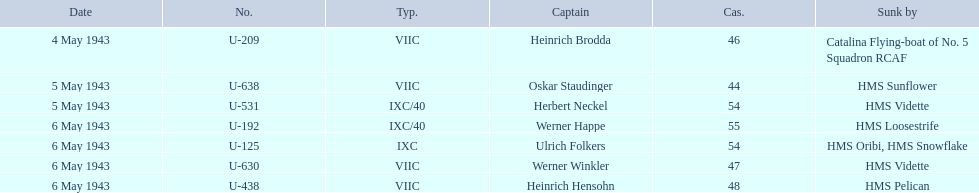Who are all of the captains? Heinrich Brodda, Oskar Staudinger, Herbert Neckel, Werner Happe, Ulrich Folkers, Werner Winkler, Heinrich Hensohn. What sunk each of the captains? Catalina Flying-boat of No. 5 Squadron RCAF, HMS Sunflower, HMS Vidette, HMS Loosestrife, HMS Oribi, HMS Snowflake, HMS Vidette, HMS Pelican. Which was sunk by the hms pelican? Heinrich Hensohn. 